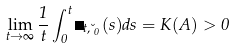<formula> <loc_0><loc_0><loc_500><loc_500>\lim _ { t \to \infty } \frac { 1 } { t } \int _ { 0 } ^ { t } \Phi _ { t , \lambda _ { 0 } } ( s ) d s = K ( A ) > 0</formula> 